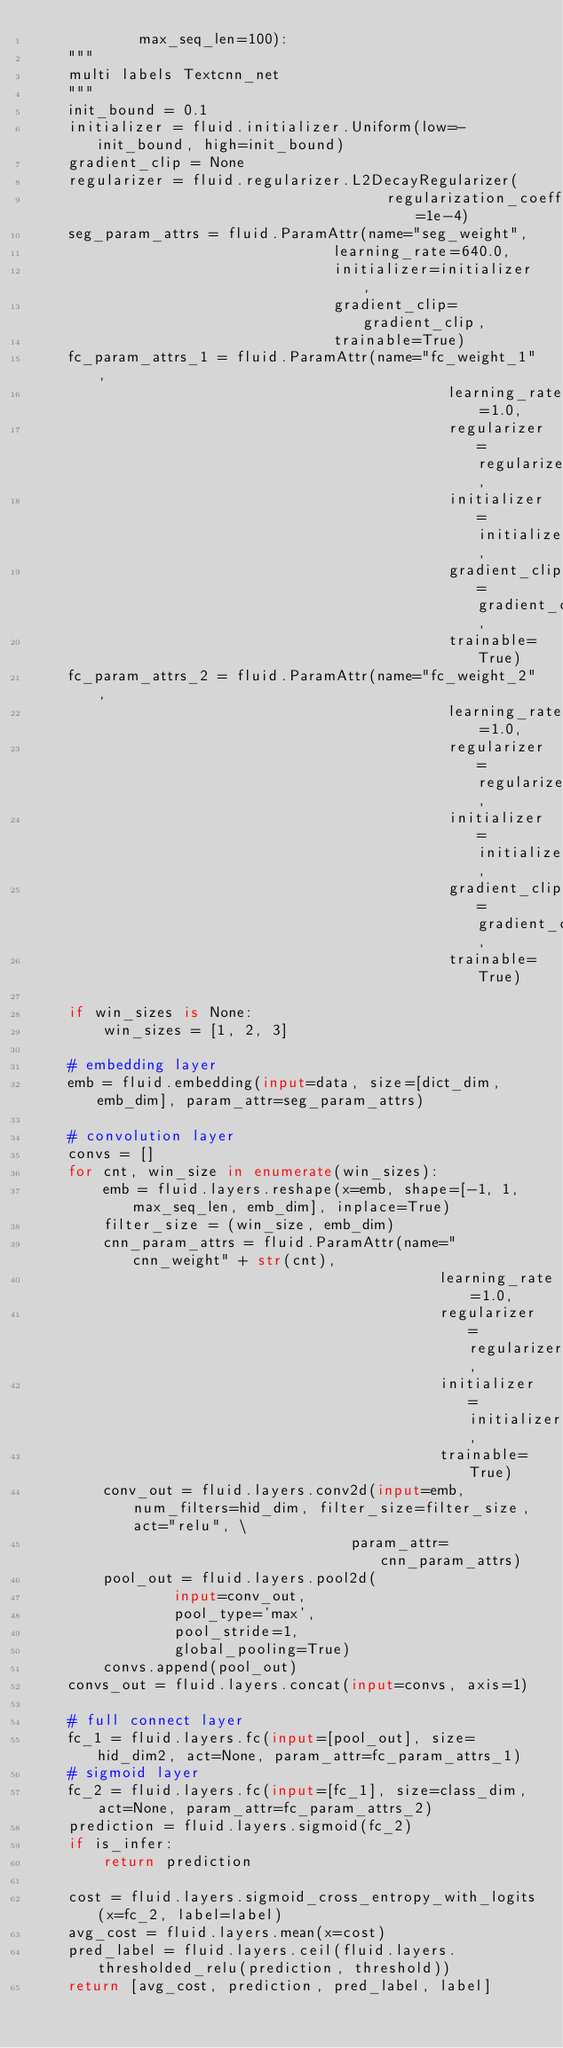<code> <loc_0><loc_0><loc_500><loc_500><_Python_>            max_seq_len=100):
    """
    multi labels Textcnn_net 
    """
    init_bound = 0.1
    initializer = fluid.initializer.Uniform(low=-init_bound, high=init_bound)
    gradient_clip = None
    regularizer = fluid.regularizer.L2DecayRegularizer(
                                        regularization_coeff=1e-4)
    seg_param_attrs = fluid.ParamAttr(name="seg_weight",
                                  learning_rate=640.0,
                                  initializer=initializer,
                                  gradient_clip=gradient_clip,
                                  trainable=True)
    fc_param_attrs_1 = fluid.ParamAttr(name="fc_weight_1",
                                               learning_rate=1.0,
                                               regularizer=regularizer,
                                               initializer=initializer,
                                               gradient_clip=gradient_clip,
                                               trainable=True)
    fc_param_attrs_2 = fluid.ParamAttr(name="fc_weight_2",
                                               learning_rate=1.0,
                                               regularizer=regularizer,
                                               initializer=initializer,
                                               gradient_clip=gradient_clip,
                                               trainable=True)

    if win_sizes is None:
        win_sizes = [1, 2, 3]

    # embedding layer
    emb = fluid.embedding(input=data, size=[dict_dim, emb_dim], param_attr=seg_param_attrs)

    # convolution layer
    convs = []
    for cnt, win_size in enumerate(win_sizes):
        emb = fluid.layers.reshape(x=emb, shape=[-1, 1, max_seq_len, emb_dim], inplace=True)
        filter_size = (win_size, emb_dim)
        cnn_param_attrs = fluid.ParamAttr(name="cnn_weight" + str(cnt),
                                              learning_rate=1.0,
                                              regularizer=regularizer,
                                              initializer=initializer,
                                              trainable=True)
        conv_out = fluid.layers.conv2d(input=emb, num_filters=hid_dim, filter_size=filter_size, act="relu", \
                                    param_attr=cnn_param_attrs)
        pool_out = fluid.layers.pool2d(
                input=conv_out,
                pool_type='max',
                pool_stride=1,
                global_pooling=True)
        convs.append(pool_out)
    convs_out = fluid.layers.concat(input=convs, axis=1)

    # full connect layer
    fc_1 = fluid.layers.fc(input=[pool_out], size=hid_dim2, act=None, param_attr=fc_param_attrs_1)
    # sigmoid layer
    fc_2 = fluid.layers.fc(input=[fc_1], size=class_dim, act=None, param_attr=fc_param_attrs_2)
    prediction = fluid.layers.sigmoid(fc_2)
    if is_infer:
        return prediction

    cost = fluid.layers.sigmoid_cross_entropy_with_logits(x=fc_2, label=label)
    avg_cost = fluid.layers.mean(x=cost)
    pred_label = fluid.layers.ceil(fluid.layers.thresholded_relu(prediction, threshold))
    return [avg_cost, prediction, pred_label, label]
</code> 